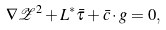Convert formula to latex. <formula><loc_0><loc_0><loc_500><loc_500>\nabla \mathcal { Z } ^ { 2 } + L ^ { * } \bar { \tau } + \bar { c } \cdot g = 0 ,</formula> 